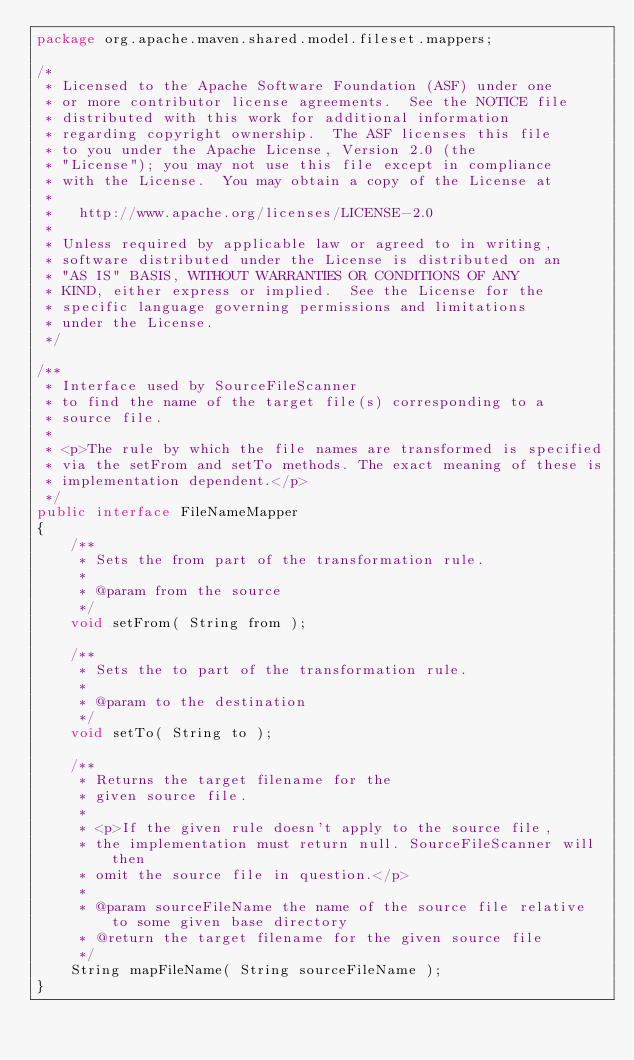Convert code to text. <code><loc_0><loc_0><loc_500><loc_500><_Java_>package org.apache.maven.shared.model.fileset.mappers;

/*
 * Licensed to the Apache Software Foundation (ASF) under one
 * or more contributor license agreements.  See the NOTICE file
 * distributed with this work for additional information
 * regarding copyright ownership.  The ASF licenses this file
 * to you under the Apache License, Version 2.0 (the
 * "License"); you may not use this file except in compliance
 * with the License.  You may obtain a copy of the License at
 *
 *   http://www.apache.org/licenses/LICENSE-2.0
 *
 * Unless required by applicable law or agreed to in writing,
 * software distributed under the License is distributed on an
 * "AS IS" BASIS, WITHOUT WARRANTIES OR CONDITIONS OF ANY
 * KIND, either express or implied.  See the License for the
 * specific language governing permissions and limitations
 * under the License.
 */

/**
 * Interface used by SourceFileScanner
 * to find the name of the target file(s) corresponding to a
 * source file.
 *
 * <p>The rule by which the file names are transformed is specified
 * via the setFrom and setTo methods. The exact meaning of these is
 * implementation dependent.</p>
 */
public interface FileNameMapper
{
    /**
     * Sets the from part of the transformation rule.
     *
     * @param from the source
     */
    void setFrom( String from );

    /**
     * Sets the to part of the transformation rule.
     *
     * @param to the destination
     */
    void setTo( String to );

    /**
     * Returns the target filename for the
     * given source file.
     *
     * <p>If the given rule doesn't apply to the source file,
     * the implementation must return null. SourceFileScanner will then
     * omit the source file in question.</p>
     *
     * @param sourceFileName the name of the source file relative to some given base directory
     * @return the target filename for the given source file
     */
    String mapFileName( String sourceFileName );
}
</code> 